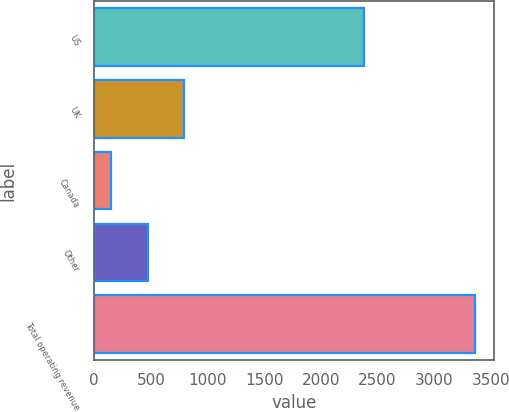Convert chart. <chart><loc_0><loc_0><loc_500><loc_500><bar_chart><fcel>US<fcel>UK<fcel>Canada<fcel>Other<fcel>Total operating revenue<nl><fcel>2379.7<fcel>791.56<fcel>148.9<fcel>470.23<fcel>3362.2<nl></chart> 